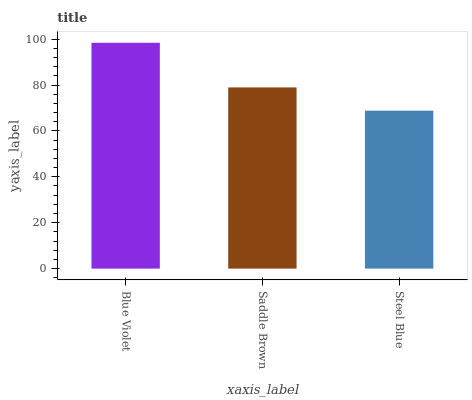Is Steel Blue the minimum?
Answer yes or no. Yes. Is Blue Violet the maximum?
Answer yes or no. Yes. Is Saddle Brown the minimum?
Answer yes or no. No. Is Saddle Brown the maximum?
Answer yes or no. No. Is Blue Violet greater than Saddle Brown?
Answer yes or no. Yes. Is Saddle Brown less than Blue Violet?
Answer yes or no. Yes. Is Saddle Brown greater than Blue Violet?
Answer yes or no. No. Is Blue Violet less than Saddle Brown?
Answer yes or no. No. Is Saddle Brown the high median?
Answer yes or no. Yes. Is Saddle Brown the low median?
Answer yes or no. Yes. Is Steel Blue the high median?
Answer yes or no. No. Is Steel Blue the low median?
Answer yes or no. No. 